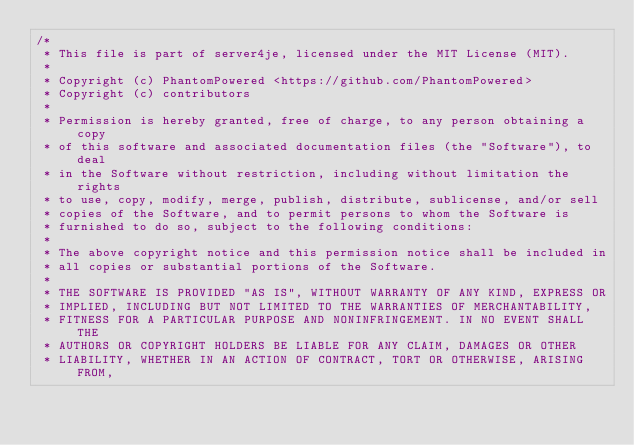Convert code to text. <code><loc_0><loc_0><loc_500><loc_500><_Java_>/*
 * This file is part of server4je, licensed under the MIT License (MIT).
 *
 * Copyright (c) PhantomPowered <https://github.com/PhantomPowered>
 * Copyright (c) contributors
 *
 * Permission is hereby granted, free of charge, to any person obtaining a copy
 * of this software and associated documentation files (the "Software"), to deal
 * in the Software without restriction, including without limitation the rights
 * to use, copy, modify, merge, publish, distribute, sublicense, and/or sell
 * copies of the Software, and to permit persons to whom the Software is
 * furnished to do so, subject to the following conditions:
 *
 * The above copyright notice and this permission notice shall be included in
 * all copies or substantial portions of the Software.
 *
 * THE SOFTWARE IS PROVIDED "AS IS", WITHOUT WARRANTY OF ANY KIND, EXPRESS OR
 * IMPLIED, INCLUDING BUT NOT LIMITED TO THE WARRANTIES OF MERCHANTABILITY,
 * FITNESS FOR A PARTICULAR PURPOSE AND NONINFRINGEMENT. IN NO EVENT SHALL THE
 * AUTHORS OR COPYRIGHT HOLDERS BE LIABLE FOR ANY CLAIM, DAMAGES OR OTHER
 * LIABILITY, WHETHER IN AN ACTION OF CONTRACT, TORT OR OTHERWISE, ARISING FROM,</code> 